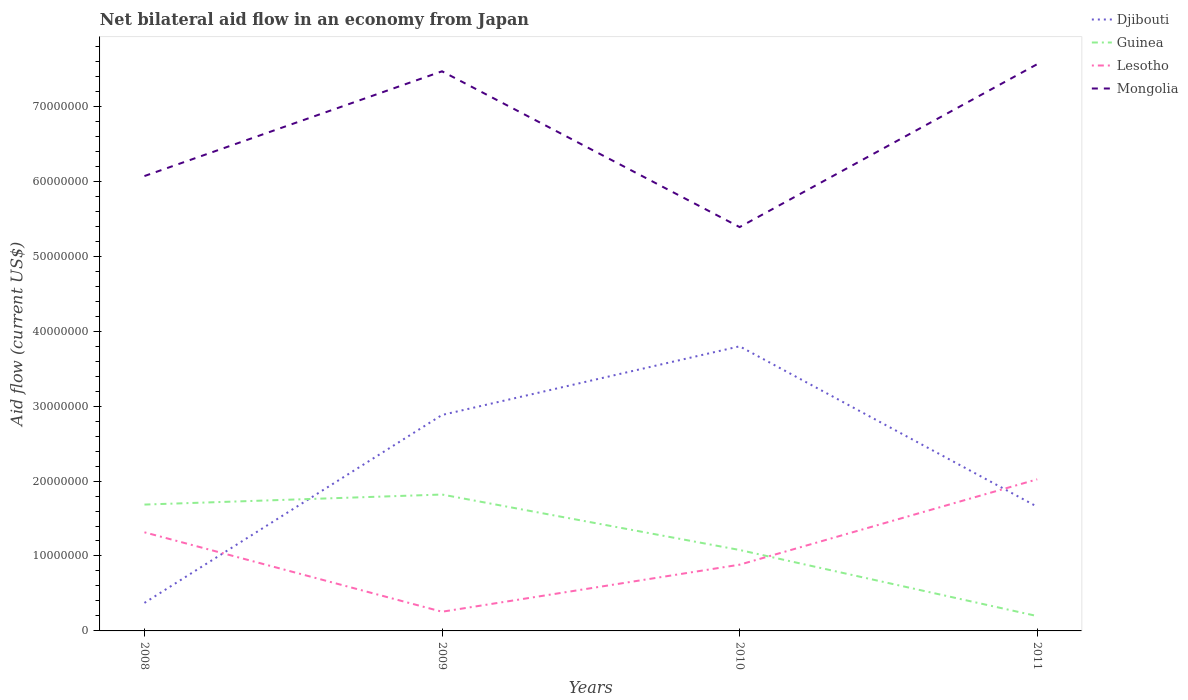How many different coloured lines are there?
Make the answer very short. 4. Does the line corresponding to Mongolia intersect with the line corresponding to Djibouti?
Make the answer very short. No. Is the number of lines equal to the number of legend labels?
Provide a short and direct response. Yes. Across all years, what is the maximum net bilateral aid flow in Djibouti?
Your response must be concise. 3.74e+06. In which year was the net bilateral aid flow in Mongolia maximum?
Your answer should be very brief. 2010. What is the total net bilateral aid flow in Guinea in the graph?
Your response must be concise. 6.06e+06. What is the difference between the highest and the second highest net bilateral aid flow in Lesotho?
Your answer should be very brief. 1.77e+07. What is the difference between the highest and the lowest net bilateral aid flow in Guinea?
Make the answer very short. 2. Is the net bilateral aid flow in Djibouti strictly greater than the net bilateral aid flow in Mongolia over the years?
Give a very brief answer. Yes. What is the difference between two consecutive major ticks on the Y-axis?
Provide a short and direct response. 1.00e+07. Are the values on the major ticks of Y-axis written in scientific E-notation?
Keep it short and to the point. No. Does the graph contain any zero values?
Your response must be concise. No. Where does the legend appear in the graph?
Keep it short and to the point. Top right. How many legend labels are there?
Your answer should be very brief. 4. How are the legend labels stacked?
Provide a succinct answer. Vertical. What is the title of the graph?
Your answer should be very brief. Net bilateral aid flow in an economy from Japan. What is the label or title of the X-axis?
Offer a terse response. Years. What is the label or title of the Y-axis?
Your answer should be compact. Aid flow (current US$). What is the Aid flow (current US$) in Djibouti in 2008?
Your answer should be compact. 3.74e+06. What is the Aid flow (current US$) in Guinea in 2008?
Ensure brevity in your answer.  1.69e+07. What is the Aid flow (current US$) of Lesotho in 2008?
Keep it short and to the point. 1.32e+07. What is the Aid flow (current US$) of Mongolia in 2008?
Make the answer very short. 6.07e+07. What is the Aid flow (current US$) in Djibouti in 2009?
Offer a very short reply. 2.88e+07. What is the Aid flow (current US$) in Guinea in 2009?
Provide a short and direct response. 1.82e+07. What is the Aid flow (current US$) of Lesotho in 2009?
Provide a short and direct response. 2.56e+06. What is the Aid flow (current US$) in Mongolia in 2009?
Make the answer very short. 7.47e+07. What is the Aid flow (current US$) of Djibouti in 2010?
Your response must be concise. 3.80e+07. What is the Aid flow (current US$) in Guinea in 2010?
Your response must be concise. 1.08e+07. What is the Aid flow (current US$) in Lesotho in 2010?
Offer a terse response. 8.84e+06. What is the Aid flow (current US$) in Mongolia in 2010?
Your answer should be compact. 5.39e+07. What is the Aid flow (current US$) in Djibouti in 2011?
Your answer should be compact. 1.66e+07. What is the Aid flow (current US$) in Guinea in 2011?
Give a very brief answer. 1.98e+06. What is the Aid flow (current US$) of Lesotho in 2011?
Your answer should be very brief. 2.02e+07. What is the Aid flow (current US$) of Mongolia in 2011?
Ensure brevity in your answer.  7.56e+07. Across all years, what is the maximum Aid flow (current US$) in Djibouti?
Your response must be concise. 3.80e+07. Across all years, what is the maximum Aid flow (current US$) of Guinea?
Your response must be concise. 1.82e+07. Across all years, what is the maximum Aid flow (current US$) in Lesotho?
Your response must be concise. 2.02e+07. Across all years, what is the maximum Aid flow (current US$) in Mongolia?
Your answer should be compact. 7.56e+07. Across all years, what is the minimum Aid flow (current US$) of Djibouti?
Your response must be concise. 3.74e+06. Across all years, what is the minimum Aid flow (current US$) in Guinea?
Make the answer very short. 1.98e+06. Across all years, what is the minimum Aid flow (current US$) in Lesotho?
Offer a terse response. 2.56e+06. Across all years, what is the minimum Aid flow (current US$) in Mongolia?
Offer a terse response. 5.39e+07. What is the total Aid flow (current US$) in Djibouti in the graph?
Offer a terse response. 8.71e+07. What is the total Aid flow (current US$) of Guinea in the graph?
Provide a succinct answer. 4.78e+07. What is the total Aid flow (current US$) of Lesotho in the graph?
Offer a terse response. 4.48e+07. What is the total Aid flow (current US$) of Mongolia in the graph?
Ensure brevity in your answer.  2.65e+08. What is the difference between the Aid flow (current US$) in Djibouti in 2008 and that in 2009?
Keep it short and to the point. -2.51e+07. What is the difference between the Aid flow (current US$) of Guinea in 2008 and that in 2009?
Your answer should be very brief. -1.34e+06. What is the difference between the Aid flow (current US$) of Lesotho in 2008 and that in 2009?
Provide a succinct answer. 1.06e+07. What is the difference between the Aid flow (current US$) of Mongolia in 2008 and that in 2009?
Your response must be concise. -1.40e+07. What is the difference between the Aid flow (current US$) of Djibouti in 2008 and that in 2010?
Offer a very short reply. -3.42e+07. What is the difference between the Aid flow (current US$) in Guinea in 2008 and that in 2010?
Give a very brief answer. 6.06e+06. What is the difference between the Aid flow (current US$) in Lesotho in 2008 and that in 2010?
Keep it short and to the point. 4.32e+06. What is the difference between the Aid flow (current US$) of Mongolia in 2008 and that in 2010?
Your response must be concise. 6.81e+06. What is the difference between the Aid flow (current US$) in Djibouti in 2008 and that in 2011?
Provide a short and direct response. -1.28e+07. What is the difference between the Aid flow (current US$) of Guinea in 2008 and that in 2011?
Offer a terse response. 1.49e+07. What is the difference between the Aid flow (current US$) of Lesotho in 2008 and that in 2011?
Give a very brief answer. -7.07e+06. What is the difference between the Aid flow (current US$) of Mongolia in 2008 and that in 2011?
Your answer should be compact. -1.49e+07. What is the difference between the Aid flow (current US$) in Djibouti in 2009 and that in 2010?
Offer a very short reply. -9.16e+06. What is the difference between the Aid flow (current US$) in Guinea in 2009 and that in 2010?
Offer a very short reply. 7.40e+06. What is the difference between the Aid flow (current US$) in Lesotho in 2009 and that in 2010?
Keep it short and to the point. -6.28e+06. What is the difference between the Aid flow (current US$) of Mongolia in 2009 and that in 2010?
Make the answer very short. 2.08e+07. What is the difference between the Aid flow (current US$) in Djibouti in 2009 and that in 2011?
Give a very brief answer. 1.22e+07. What is the difference between the Aid flow (current US$) of Guinea in 2009 and that in 2011?
Give a very brief answer. 1.62e+07. What is the difference between the Aid flow (current US$) of Lesotho in 2009 and that in 2011?
Make the answer very short. -1.77e+07. What is the difference between the Aid flow (current US$) in Mongolia in 2009 and that in 2011?
Your response must be concise. -9.50e+05. What is the difference between the Aid flow (current US$) of Djibouti in 2010 and that in 2011?
Offer a terse response. 2.14e+07. What is the difference between the Aid flow (current US$) of Guinea in 2010 and that in 2011?
Offer a very short reply. 8.82e+06. What is the difference between the Aid flow (current US$) of Lesotho in 2010 and that in 2011?
Offer a terse response. -1.14e+07. What is the difference between the Aid flow (current US$) in Mongolia in 2010 and that in 2011?
Offer a terse response. -2.17e+07. What is the difference between the Aid flow (current US$) of Djibouti in 2008 and the Aid flow (current US$) of Guinea in 2009?
Make the answer very short. -1.45e+07. What is the difference between the Aid flow (current US$) in Djibouti in 2008 and the Aid flow (current US$) in Lesotho in 2009?
Provide a succinct answer. 1.18e+06. What is the difference between the Aid flow (current US$) in Djibouti in 2008 and the Aid flow (current US$) in Mongolia in 2009?
Your response must be concise. -7.09e+07. What is the difference between the Aid flow (current US$) in Guinea in 2008 and the Aid flow (current US$) in Lesotho in 2009?
Offer a terse response. 1.43e+07. What is the difference between the Aid flow (current US$) of Guinea in 2008 and the Aid flow (current US$) of Mongolia in 2009?
Your response must be concise. -5.78e+07. What is the difference between the Aid flow (current US$) in Lesotho in 2008 and the Aid flow (current US$) in Mongolia in 2009?
Give a very brief answer. -6.15e+07. What is the difference between the Aid flow (current US$) of Djibouti in 2008 and the Aid flow (current US$) of Guinea in 2010?
Provide a succinct answer. -7.06e+06. What is the difference between the Aid flow (current US$) in Djibouti in 2008 and the Aid flow (current US$) in Lesotho in 2010?
Provide a short and direct response. -5.10e+06. What is the difference between the Aid flow (current US$) in Djibouti in 2008 and the Aid flow (current US$) in Mongolia in 2010?
Make the answer very short. -5.02e+07. What is the difference between the Aid flow (current US$) in Guinea in 2008 and the Aid flow (current US$) in Lesotho in 2010?
Your response must be concise. 8.02e+06. What is the difference between the Aid flow (current US$) of Guinea in 2008 and the Aid flow (current US$) of Mongolia in 2010?
Provide a succinct answer. -3.70e+07. What is the difference between the Aid flow (current US$) in Lesotho in 2008 and the Aid flow (current US$) in Mongolia in 2010?
Give a very brief answer. -4.07e+07. What is the difference between the Aid flow (current US$) of Djibouti in 2008 and the Aid flow (current US$) of Guinea in 2011?
Offer a terse response. 1.76e+06. What is the difference between the Aid flow (current US$) in Djibouti in 2008 and the Aid flow (current US$) in Lesotho in 2011?
Make the answer very short. -1.65e+07. What is the difference between the Aid flow (current US$) in Djibouti in 2008 and the Aid flow (current US$) in Mongolia in 2011?
Provide a short and direct response. -7.19e+07. What is the difference between the Aid flow (current US$) of Guinea in 2008 and the Aid flow (current US$) of Lesotho in 2011?
Your response must be concise. -3.37e+06. What is the difference between the Aid flow (current US$) in Guinea in 2008 and the Aid flow (current US$) in Mongolia in 2011?
Provide a short and direct response. -5.88e+07. What is the difference between the Aid flow (current US$) in Lesotho in 2008 and the Aid flow (current US$) in Mongolia in 2011?
Keep it short and to the point. -6.25e+07. What is the difference between the Aid flow (current US$) in Djibouti in 2009 and the Aid flow (current US$) in Guinea in 2010?
Make the answer very short. 1.80e+07. What is the difference between the Aid flow (current US$) of Djibouti in 2009 and the Aid flow (current US$) of Lesotho in 2010?
Keep it short and to the point. 2.00e+07. What is the difference between the Aid flow (current US$) of Djibouti in 2009 and the Aid flow (current US$) of Mongolia in 2010?
Your answer should be very brief. -2.51e+07. What is the difference between the Aid flow (current US$) of Guinea in 2009 and the Aid flow (current US$) of Lesotho in 2010?
Your answer should be compact. 9.36e+06. What is the difference between the Aid flow (current US$) in Guinea in 2009 and the Aid flow (current US$) in Mongolia in 2010?
Provide a short and direct response. -3.57e+07. What is the difference between the Aid flow (current US$) of Lesotho in 2009 and the Aid flow (current US$) of Mongolia in 2010?
Your answer should be very brief. -5.13e+07. What is the difference between the Aid flow (current US$) of Djibouti in 2009 and the Aid flow (current US$) of Guinea in 2011?
Make the answer very short. 2.68e+07. What is the difference between the Aid flow (current US$) in Djibouti in 2009 and the Aid flow (current US$) in Lesotho in 2011?
Give a very brief answer. 8.59e+06. What is the difference between the Aid flow (current US$) of Djibouti in 2009 and the Aid flow (current US$) of Mongolia in 2011?
Your response must be concise. -4.68e+07. What is the difference between the Aid flow (current US$) in Guinea in 2009 and the Aid flow (current US$) in Lesotho in 2011?
Provide a succinct answer. -2.03e+06. What is the difference between the Aid flow (current US$) of Guinea in 2009 and the Aid flow (current US$) of Mongolia in 2011?
Your answer should be compact. -5.74e+07. What is the difference between the Aid flow (current US$) of Lesotho in 2009 and the Aid flow (current US$) of Mongolia in 2011?
Keep it short and to the point. -7.31e+07. What is the difference between the Aid flow (current US$) in Djibouti in 2010 and the Aid flow (current US$) in Guinea in 2011?
Provide a short and direct response. 3.60e+07. What is the difference between the Aid flow (current US$) in Djibouti in 2010 and the Aid flow (current US$) in Lesotho in 2011?
Make the answer very short. 1.78e+07. What is the difference between the Aid flow (current US$) in Djibouti in 2010 and the Aid flow (current US$) in Mongolia in 2011?
Your answer should be compact. -3.76e+07. What is the difference between the Aid flow (current US$) in Guinea in 2010 and the Aid flow (current US$) in Lesotho in 2011?
Keep it short and to the point. -9.43e+06. What is the difference between the Aid flow (current US$) of Guinea in 2010 and the Aid flow (current US$) of Mongolia in 2011?
Your answer should be compact. -6.48e+07. What is the difference between the Aid flow (current US$) in Lesotho in 2010 and the Aid flow (current US$) in Mongolia in 2011?
Provide a short and direct response. -6.68e+07. What is the average Aid flow (current US$) of Djibouti per year?
Ensure brevity in your answer.  2.18e+07. What is the average Aid flow (current US$) of Guinea per year?
Make the answer very short. 1.20e+07. What is the average Aid flow (current US$) in Lesotho per year?
Offer a very short reply. 1.12e+07. What is the average Aid flow (current US$) of Mongolia per year?
Your response must be concise. 6.62e+07. In the year 2008, what is the difference between the Aid flow (current US$) in Djibouti and Aid flow (current US$) in Guinea?
Make the answer very short. -1.31e+07. In the year 2008, what is the difference between the Aid flow (current US$) in Djibouti and Aid flow (current US$) in Lesotho?
Ensure brevity in your answer.  -9.42e+06. In the year 2008, what is the difference between the Aid flow (current US$) in Djibouti and Aid flow (current US$) in Mongolia?
Offer a terse response. -5.70e+07. In the year 2008, what is the difference between the Aid flow (current US$) in Guinea and Aid flow (current US$) in Lesotho?
Offer a terse response. 3.70e+06. In the year 2008, what is the difference between the Aid flow (current US$) of Guinea and Aid flow (current US$) of Mongolia?
Keep it short and to the point. -4.38e+07. In the year 2008, what is the difference between the Aid flow (current US$) in Lesotho and Aid flow (current US$) in Mongolia?
Your answer should be compact. -4.75e+07. In the year 2009, what is the difference between the Aid flow (current US$) of Djibouti and Aid flow (current US$) of Guinea?
Offer a very short reply. 1.06e+07. In the year 2009, what is the difference between the Aid flow (current US$) of Djibouti and Aid flow (current US$) of Lesotho?
Offer a terse response. 2.63e+07. In the year 2009, what is the difference between the Aid flow (current US$) in Djibouti and Aid flow (current US$) in Mongolia?
Provide a succinct answer. -4.59e+07. In the year 2009, what is the difference between the Aid flow (current US$) in Guinea and Aid flow (current US$) in Lesotho?
Make the answer very short. 1.56e+07. In the year 2009, what is the difference between the Aid flow (current US$) of Guinea and Aid flow (current US$) of Mongolia?
Your answer should be compact. -5.65e+07. In the year 2009, what is the difference between the Aid flow (current US$) of Lesotho and Aid flow (current US$) of Mongolia?
Keep it short and to the point. -7.21e+07. In the year 2010, what is the difference between the Aid flow (current US$) of Djibouti and Aid flow (current US$) of Guinea?
Your response must be concise. 2.72e+07. In the year 2010, what is the difference between the Aid flow (current US$) of Djibouti and Aid flow (current US$) of Lesotho?
Keep it short and to the point. 2.91e+07. In the year 2010, what is the difference between the Aid flow (current US$) in Djibouti and Aid flow (current US$) in Mongolia?
Your answer should be compact. -1.59e+07. In the year 2010, what is the difference between the Aid flow (current US$) of Guinea and Aid flow (current US$) of Lesotho?
Keep it short and to the point. 1.96e+06. In the year 2010, what is the difference between the Aid flow (current US$) in Guinea and Aid flow (current US$) in Mongolia?
Your answer should be compact. -4.31e+07. In the year 2010, what is the difference between the Aid flow (current US$) of Lesotho and Aid flow (current US$) of Mongolia?
Ensure brevity in your answer.  -4.50e+07. In the year 2011, what is the difference between the Aid flow (current US$) in Djibouti and Aid flow (current US$) in Guinea?
Make the answer very short. 1.46e+07. In the year 2011, what is the difference between the Aid flow (current US$) in Djibouti and Aid flow (current US$) in Lesotho?
Your response must be concise. -3.66e+06. In the year 2011, what is the difference between the Aid flow (current US$) in Djibouti and Aid flow (current US$) in Mongolia?
Ensure brevity in your answer.  -5.91e+07. In the year 2011, what is the difference between the Aid flow (current US$) of Guinea and Aid flow (current US$) of Lesotho?
Your answer should be very brief. -1.82e+07. In the year 2011, what is the difference between the Aid flow (current US$) in Guinea and Aid flow (current US$) in Mongolia?
Provide a short and direct response. -7.36e+07. In the year 2011, what is the difference between the Aid flow (current US$) in Lesotho and Aid flow (current US$) in Mongolia?
Ensure brevity in your answer.  -5.54e+07. What is the ratio of the Aid flow (current US$) of Djibouti in 2008 to that in 2009?
Keep it short and to the point. 0.13. What is the ratio of the Aid flow (current US$) in Guinea in 2008 to that in 2009?
Your answer should be compact. 0.93. What is the ratio of the Aid flow (current US$) of Lesotho in 2008 to that in 2009?
Your response must be concise. 5.14. What is the ratio of the Aid flow (current US$) of Mongolia in 2008 to that in 2009?
Make the answer very short. 0.81. What is the ratio of the Aid flow (current US$) of Djibouti in 2008 to that in 2010?
Your response must be concise. 0.1. What is the ratio of the Aid flow (current US$) in Guinea in 2008 to that in 2010?
Your answer should be compact. 1.56. What is the ratio of the Aid flow (current US$) of Lesotho in 2008 to that in 2010?
Offer a very short reply. 1.49. What is the ratio of the Aid flow (current US$) in Mongolia in 2008 to that in 2010?
Ensure brevity in your answer.  1.13. What is the ratio of the Aid flow (current US$) in Djibouti in 2008 to that in 2011?
Provide a succinct answer. 0.23. What is the ratio of the Aid flow (current US$) of Guinea in 2008 to that in 2011?
Make the answer very short. 8.52. What is the ratio of the Aid flow (current US$) in Lesotho in 2008 to that in 2011?
Ensure brevity in your answer.  0.65. What is the ratio of the Aid flow (current US$) in Mongolia in 2008 to that in 2011?
Ensure brevity in your answer.  0.8. What is the ratio of the Aid flow (current US$) in Djibouti in 2009 to that in 2010?
Offer a terse response. 0.76. What is the ratio of the Aid flow (current US$) in Guinea in 2009 to that in 2010?
Offer a very short reply. 1.69. What is the ratio of the Aid flow (current US$) of Lesotho in 2009 to that in 2010?
Provide a short and direct response. 0.29. What is the ratio of the Aid flow (current US$) of Mongolia in 2009 to that in 2010?
Make the answer very short. 1.39. What is the ratio of the Aid flow (current US$) in Djibouti in 2009 to that in 2011?
Make the answer very short. 1.74. What is the ratio of the Aid flow (current US$) in Guinea in 2009 to that in 2011?
Offer a terse response. 9.19. What is the ratio of the Aid flow (current US$) in Lesotho in 2009 to that in 2011?
Offer a very short reply. 0.13. What is the ratio of the Aid flow (current US$) in Mongolia in 2009 to that in 2011?
Your response must be concise. 0.99. What is the ratio of the Aid flow (current US$) of Djibouti in 2010 to that in 2011?
Provide a short and direct response. 2.29. What is the ratio of the Aid flow (current US$) in Guinea in 2010 to that in 2011?
Offer a terse response. 5.45. What is the ratio of the Aid flow (current US$) in Lesotho in 2010 to that in 2011?
Your response must be concise. 0.44. What is the ratio of the Aid flow (current US$) in Mongolia in 2010 to that in 2011?
Your answer should be very brief. 0.71. What is the difference between the highest and the second highest Aid flow (current US$) of Djibouti?
Provide a short and direct response. 9.16e+06. What is the difference between the highest and the second highest Aid flow (current US$) in Guinea?
Ensure brevity in your answer.  1.34e+06. What is the difference between the highest and the second highest Aid flow (current US$) of Lesotho?
Provide a short and direct response. 7.07e+06. What is the difference between the highest and the second highest Aid flow (current US$) of Mongolia?
Ensure brevity in your answer.  9.50e+05. What is the difference between the highest and the lowest Aid flow (current US$) in Djibouti?
Provide a succinct answer. 3.42e+07. What is the difference between the highest and the lowest Aid flow (current US$) in Guinea?
Make the answer very short. 1.62e+07. What is the difference between the highest and the lowest Aid flow (current US$) in Lesotho?
Your answer should be very brief. 1.77e+07. What is the difference between the highest and the lowest Aid flow (current US$) in Mongolia?
Offer a terse response. 2.17e+07. 